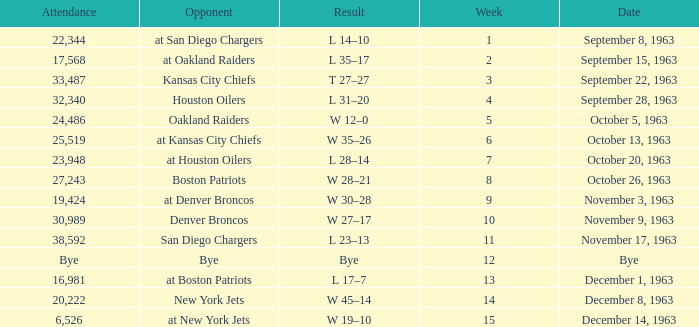Which rival has a result of 14-10? At san diego chargers. 